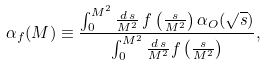<formula> <loc_0><loc_0><loc_500><loc_500>\alpha _ { f } ( M ) \equiv \frac { \int ^ { M ^ { 2 } } _ { 0 } \frac { d \, s } { M ^ { 2 } } \, f \left ( \frac { s } { M ^ { 2 } } \right ) \alpha _ { O } ( \sqrt { s } ) } { \int ^ { M ^ { 2 } } _ { 0 } \frac { d \, s } { M ^ { 2 } } f \left ( \frac { s } { M ^ { 2 } } \right ) } ,</formula> 